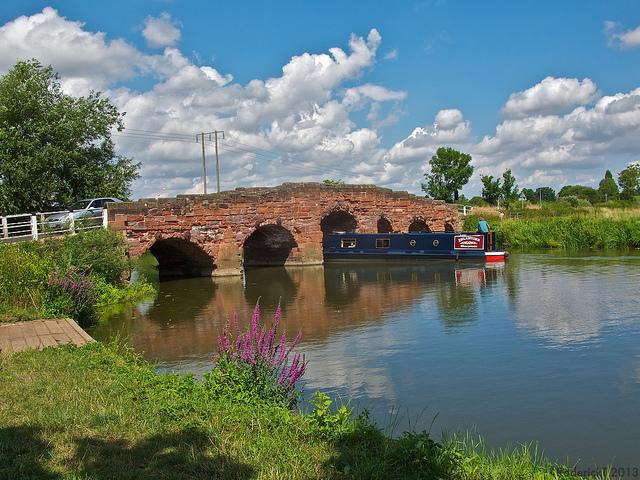Where is the boat going? Please explain your reasoning. under bridge. You can tell by the structure and how it was built as to what the boat is going under. 